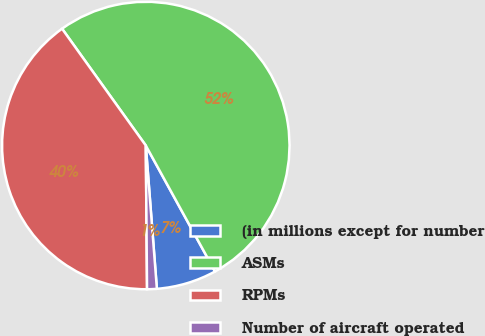Convert chart. <chart><loc_0><loc_0><loc_500><loc_500><pie_chart><fcel>(in millions except for number<fcel>ASMs<fcel>RPMs<fcel>Number of aircraft operated<nl><fcel>6.77%<fcel>51.9%<fcel>40.24%<fcel>1.09%<nl></chart> 